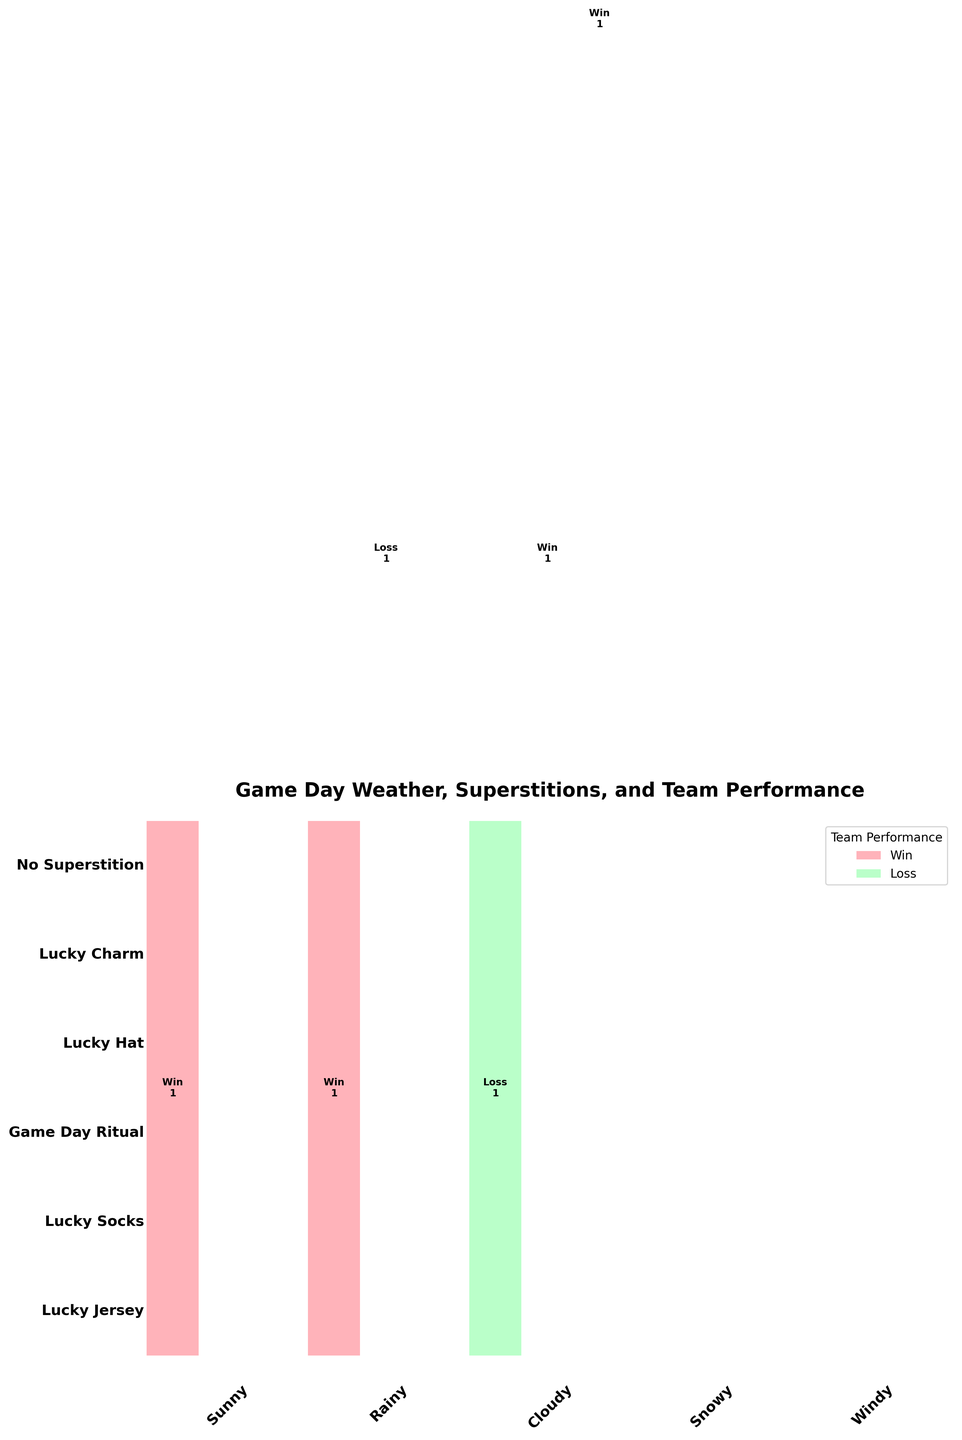What is the title of the figure? The title of the figure is written at the top, which provides an overview of the plot's subject.
Answer: Game Day Weather, Superstitions, and Team Performance Which team performance outcome is represented by the light pink color? The legend on the upper right of the figure shows that the light pink color corresponds to a specific team performance outcome.
Answer: Loss In which weather condition did the team have the highest number of wins? By looking at the bars with the dark pink color (representing wins), we can identify the weather condition with the tallest bar segment in that color.
Answer: Windy How many total game outcomes are present for the "Lucky Jersey" superstition? By summing up the numbers inside all the cells corresponding to the "Lucky Jersey" superstition, we find the total number.
Answer: 3 What is the most common superstition when the weather is sunny? Observing the width of the bars associated with each superstition under the "Sunny" weather condition reveals the most common one.
Answer: Lucky Charm Which weather condition had the least number of losses? By examining the height of the light pink bars (representing losses) for each weather condition, we find the one with the shortest combined height.
Answer: Rainy Compare the number of wins under the "Lucky Socks" superstition with the number of wins under the "Lucky Hat" superstition. Which one is greater? By comparing the sum of the numbers in the dark pink sections corresponding to "Lucky Socks" and "Lucky Hat," we determine which one is greater.
Answer: Lucky Socks How many losses occurred on cloudy days? Adding the numbers in the light pink sections under the "Cloudy" weather condition gives the total losses.
Answer: 1 Which superstition resulted in the highest number of wins overall? Summing the number of wins (dark pink) across all weather conditions for each superstition and comparing these sums will show the superstition with the highest number of wins.
Answer: Game Day Ritual Among the superstitions, which one had an equal number of wins and losses? For each superstition, compare the count of wins and losses. The superstition with the same count for both will meet the criteria.
Answer: Lucky Hat 